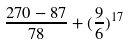Convert formula to latex. <formula><loc_0><loc_0><loc_500><loc_500>\frac { 2 7 0 - 8 7 } { 7 8 } + ( \frac { 9 } { 6 } ) ^ { 1 7 }</formula> 